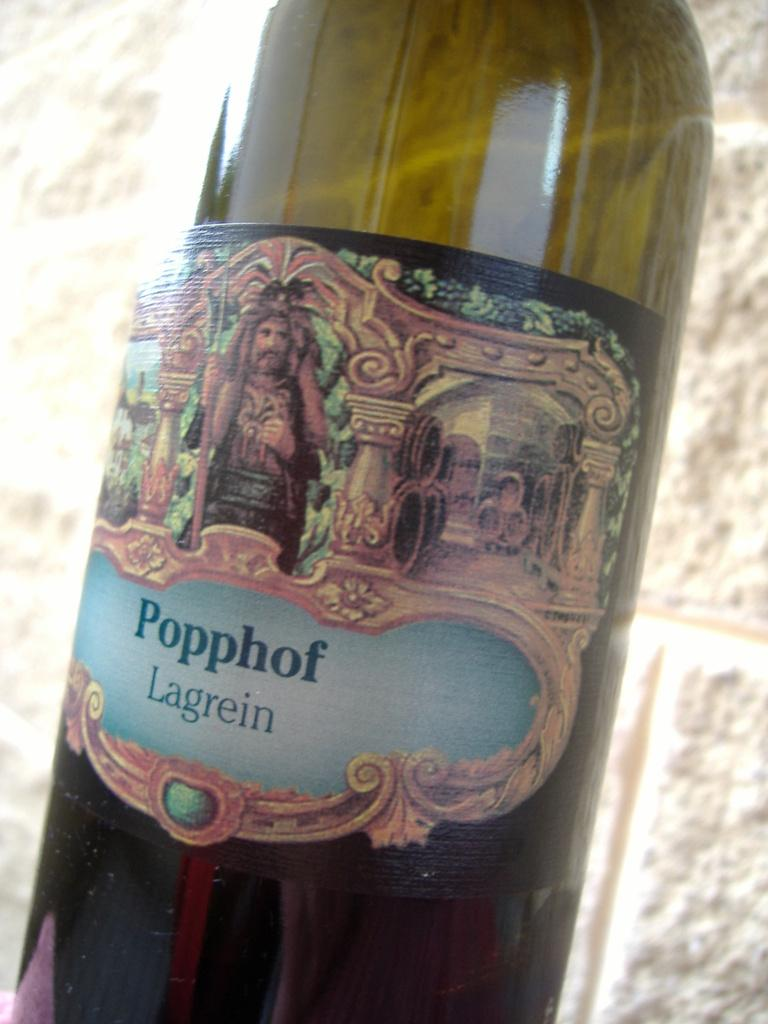<image>
Present a compact description of the photo's key features. A bottle of Popphof Lagrein has an antique looking label 